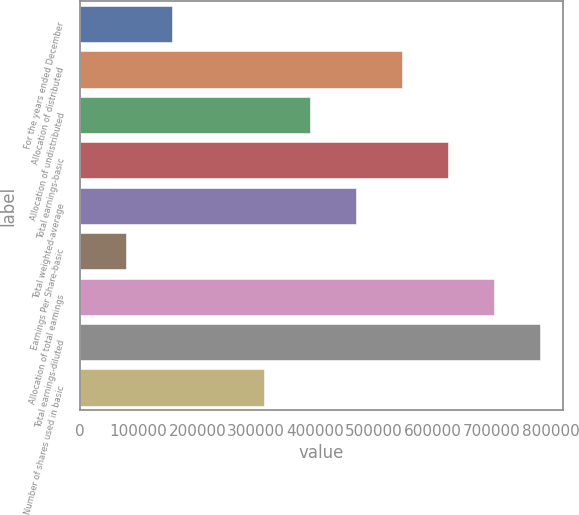Convert chart to OTSL. <chart><loc_0><loc_0><loc_500><loc_500><bar_chart><fcel>For the years ended December<fcel>Allocation of distributed<fcel>Allocation of undistributed<fcel>Total earnings-basic<fcel>Total weighted-average<fcel>Earnings Per Share-basic<fcel>Allocation of total earnings<fcel>Total earnings-diluted<fcel>Number of shares used in basic<nl><fcel>156599<fcel>548088<fcel>391492<fcel>626386<fcel>469790<fcel>78301.4<fcel>704683<fcel>782981<fcel>313195<nl></chart> 